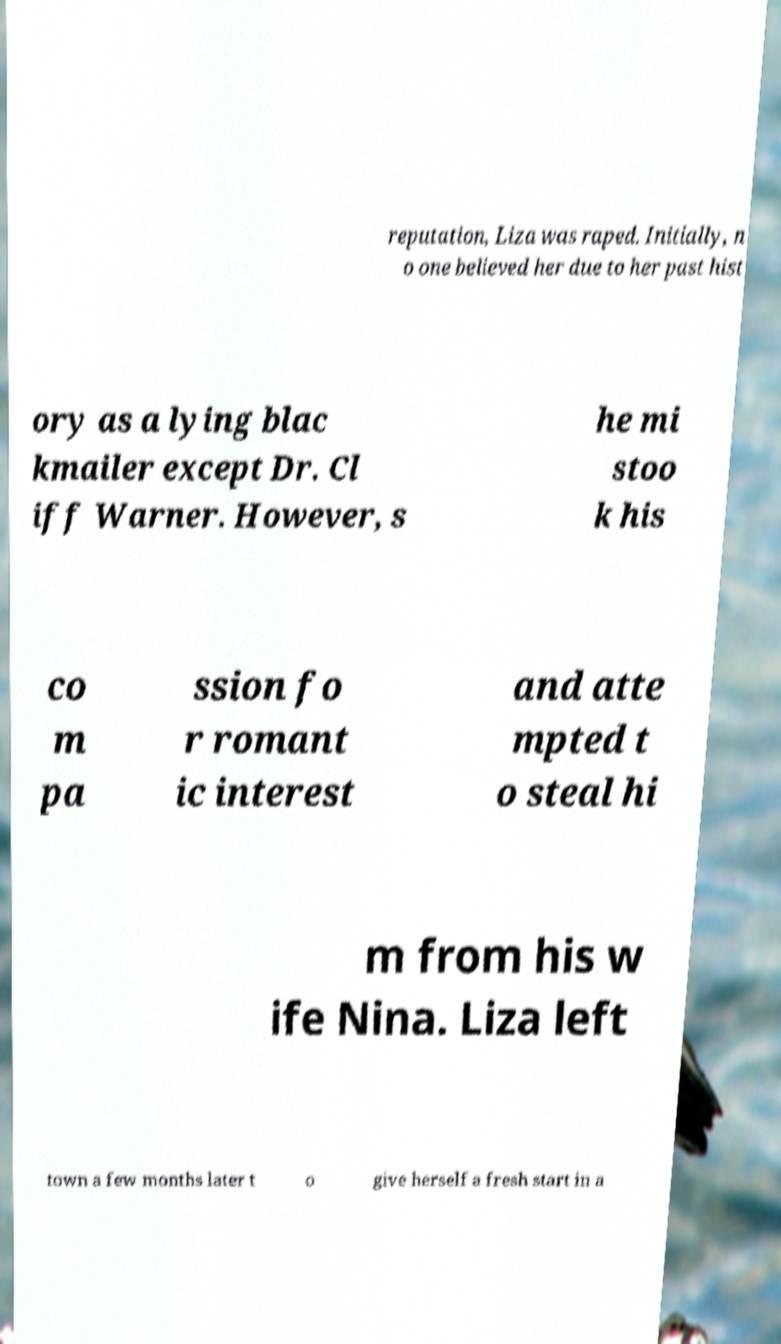Can you accurately transcribe the text from the provided image for me? reputation, Liza was raped. Initially, n o one believed her due to her past hist ory as a lying blac kmailer except Dr. Cl iff Warner. However, s he mi stoo k his co m pa ssion fo r romant ic interest and atte mpted t o steal hi m from his w ife Nina. Liza left town a few months later t o give herself a fresh start in a 